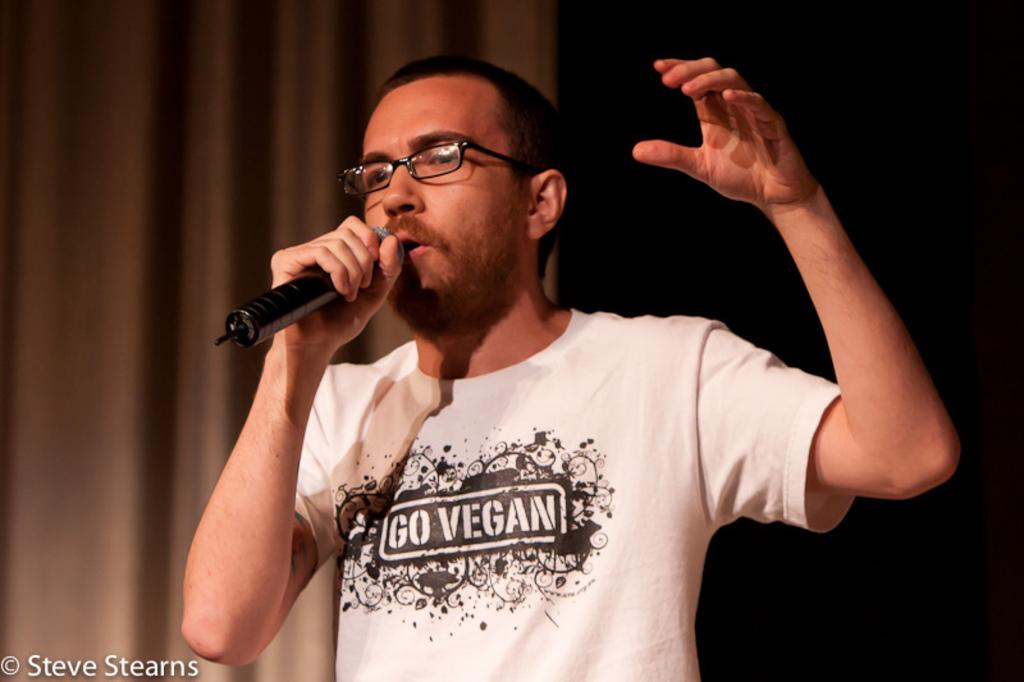What is the man in the image doing? The man is speaking into a microphone. What is the man wearing in the image? The man is wearing a t-shirt. Can you describe any additional features of the image? There is a watermark in the left-hand side bottom of the image. Is the man playing a drum in the image? No, the man is not playing a drum in the image; he is speaking into a microphone. Can you tell me how many basketballs are visible in the image? There are no basketballs present in the image. 